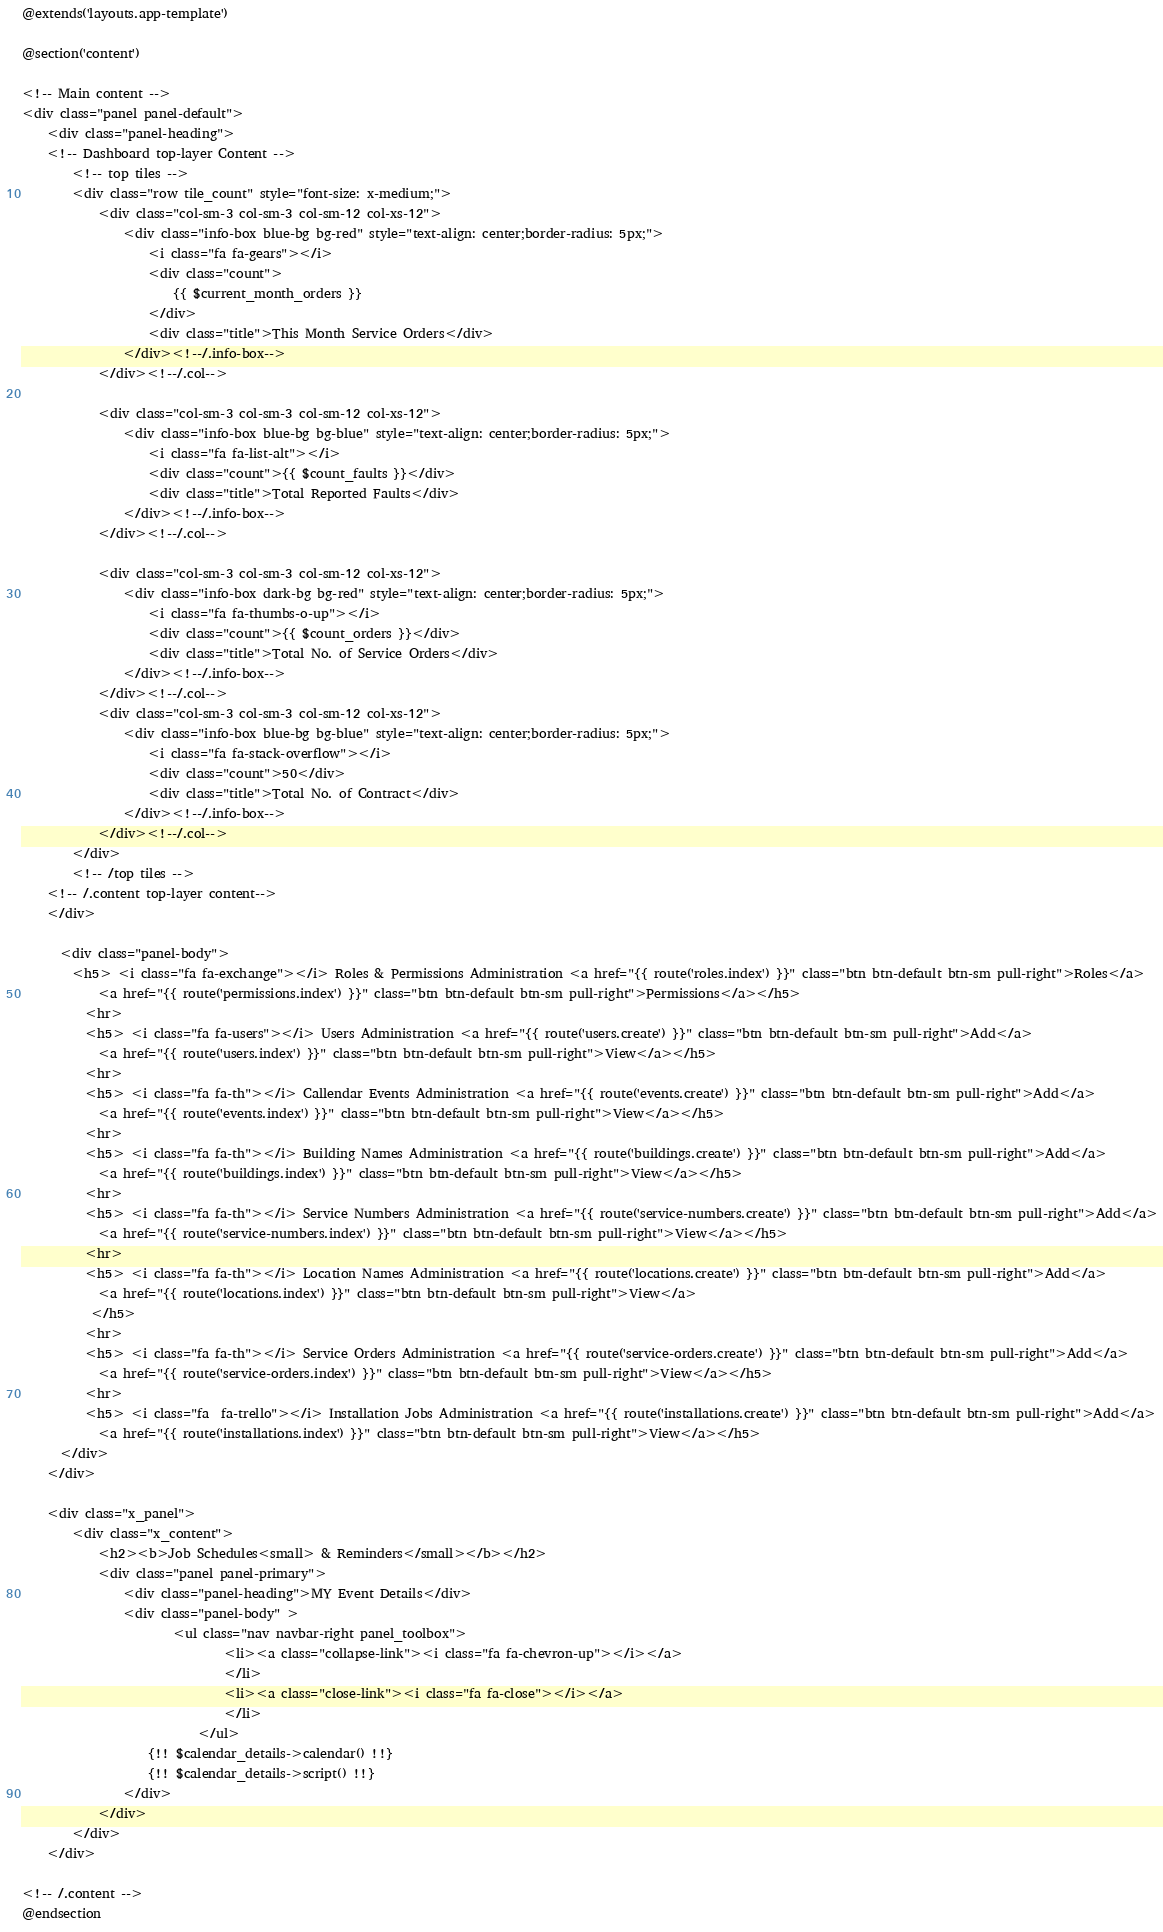Convert code to text. <code><loc_0><loc_0><loc_500><loc_500><_PHP_>@extends('layouts.app-template')

@section('content')
  
<!-- Main content -->
<div class="panel panel-default">
    <div class="panel-heading">
	<!-- Dashboard top-layer Content -->
		<!-- top tiles -->
		<div class="row tile_count" style="font-size: x-medium;">
			<div class="col-sm-3 col-sm-3 col-sm-12 col-xs-12">
				<div class="info-box blue-bg bg-red" style="text-align: center;border-radius: 5px;">
					<i class="fa fa-gears"></i>
					<div class="count">
						{{ $current_month_orders }}
					</div>
					<div class="title">This Month Service Orders</div>
				</div><!--/.info-box-->
			</div><!--/.col-->

			<div class="col-sm-3 col-sm-3 col-sm-12 col-xs-12">
				<div class="info-box blue-bg bg-blue" style="text-align: center;border-radius: 5px;">
					<i class="fa fa-list-alt"></i>
					<div class="count">{{ $count_faults }}</div>
					<div class="title">Total Reported Faults</div>
				</div><!--/.info-box-->
			</div><!--/.col-->

			<div class="col-sm-3 col-sm-3 col-sm-12 col-xs-12">
				<div class="info-box dark-bg bg-red" style="text-align: center;border-radius: 5px;">
					<i class="fa fa-thumbs-o-up"></i>
					<div class="count">{{ $count_orders }}</div>
					<div class="title">Total No. of Service Orders</div>
				</div><!--/.info-box-->
			</div><!--/.col-->
			<div class="col-sm-3 col-sm-3 col-sm-12 col-xs-12">
				<div class="info-box blue-bg bg-blue" style="text-align: center;border-radius: 5px;">
					<i class="fa fa-stack-overflow"></i>
					<div class="count">50</div>
					<div class="title">Total No. of Contract</div>
				</div><!--/.info-box-->
			</div><!--/.col-->
		</div>
		<!-- /top tiles -->
	<!-- /.content top-layer content-->
	</div>
			
      <div class="panel-body">
        <h5> <i class="fa fa-exchange"></i> Roles & Permissions Administration <a href="{{ route('roles.index') }}" class="btn btn-default btn-sm pull-right">Roles</a>
        	<a href="{{ route('permissions.index') }}" class="btn btn-default btn-sm pull-right">Permissions</a></h5>
          <hr>
          <h5> <i class="fa fa-users"></i> Users Administration <a href="{{ route('users.create') }}" class="btn btn-default btn-sm pull-right">Add</a>
            <a href="{{ route('users.index') }}" class="btn btn-default btn-sm pull-right">View</a></h5>
		  <hr>
		  <h5> <i class="fa fa-th"></i> Callendar Events Administration <a href="{{ route('events.create') }}" class="btn btn-default btn-sm pull-right">Add</a>
            <a href="{{ route('events.index') }}" class="btn btn-default btn-sm pull-right">View</a></h5>
		  <hr>
		  <h5> <i class="fa fa-th"></i> Building Names Administration <a href="{{ route('buildings.create') }}" class="btn btn-default btn-sm pull-right">Add</a>
            <a href="{{ route('buildings.index') }}" class="btn btn-default btn-sm pull-right">View</a></h5>
		  <hr>
		  <h5> <i class="fa fa-th"></i> Service Numbers Administration <a href="{{ route('service-numbers.create') }}" class="btn btn-default btn-sm pull-right">Add</a>
            <a href="{{ route('service-numbers.index') }}" class="btn btn-default btn-sm pull-right">View</a></h5>
		  <hr>
		  <h5> <i class="fa fa-th"></i> Location Names Administration <a href="{{ route('locations.create') }}" class="btn btn-default btn-sm pull-right">Add</a>
			<a href="{{ route('locations.index') }}" class="btn btn-default btn-sm pull-right">View</a>
		   </h5>
          <hr>
          <h5> <i class="fa fa-th"></i> Service Orders Administration <a href="{{ route('service-orders.create') }}" class="btn btn-default btn-sm pull-right">Add</a>
            <a href="{{ route('service-orders.index') }}" class="btn btn-default btn-sm pull-right">View</a></h5>
          <hr>
          <h5> <i class="fa  fa-trello"></i> Installation Jobs Administration <a href="{{ route('installations.create') }}" class="btn btn-default btn-sm pull-right">Add</a>
            <a href="{{ route('installations.index') }}" class="btn btn-default btn-sm pull-right">View</a></h5>
      </div>
    </div>

  	<div class="x_panel">
		<div class="x_content">	
			<h2><b>Job Schedules<small> & Reminders</small></b></h2>
			<div class="panel panel-primary">
				<div class="panel-heading">MY Event Details</div>
				<div class="panel-body" >
						<ul class="nav navbar-right panel_toolbox">
								<li><a class="collapse-link"><i class="fa fa-chevron-up"></i></a>
								</li>
								<li><a class="close-link"><i class="fa fa-close"></i></a>
								</li>
							</ul>
					{!! $calendar_details->calendar() !!}
					{!! $calendar_details->script() !!}
				</div>
			</div>
		</div>
	</div>

<!-- /.content -->
@endsection

</code> 